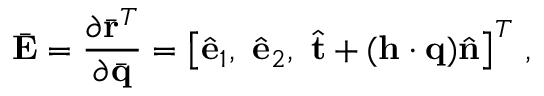<formula> <loc_0><loc_0><loc_500><loc_500>\bar { E } = \frac { \partial \bar { r } ^ { T } } { \partial \bar { q } } = \left [ \hat { e } _ { 1 } , \ \hat { e } _ { 2 } , \ \hat { t } + ( { h } \cdot { q } ) \hat { n } \right ] ^ { T } \, ,</formula> 